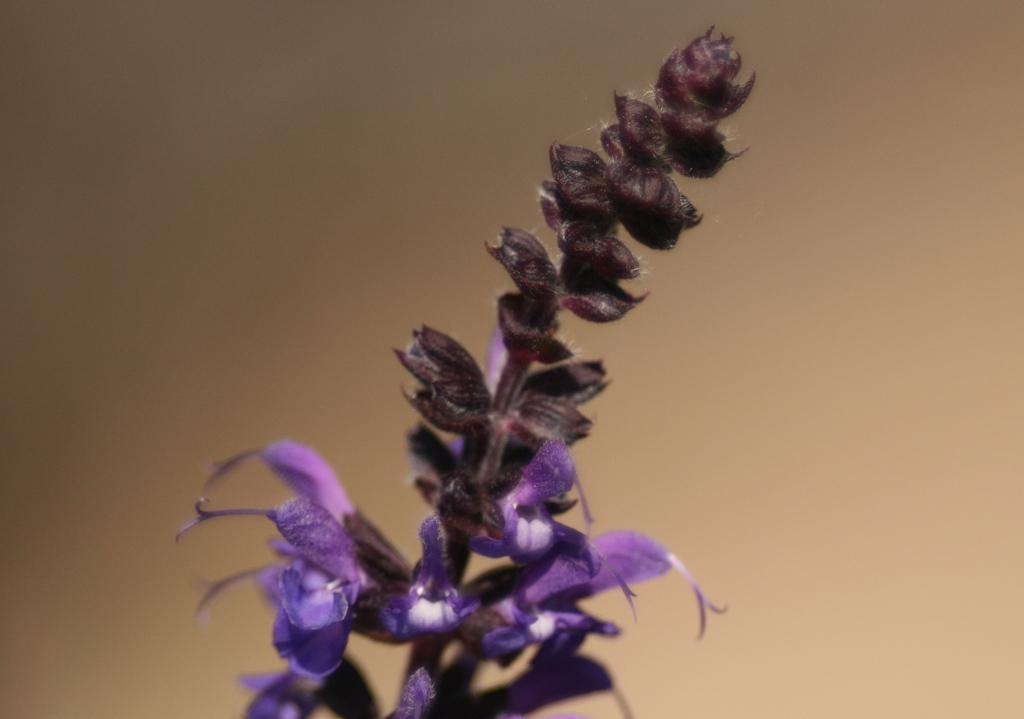What color are the flowers in the image? The flowers in the image are violet. Can you describe any other features of the flowers? There are buds on a stem in the image. What type of polish is being applied to the book in the image? There is no book or polish present in the image; it only features violet flowers and buds on a stem. 